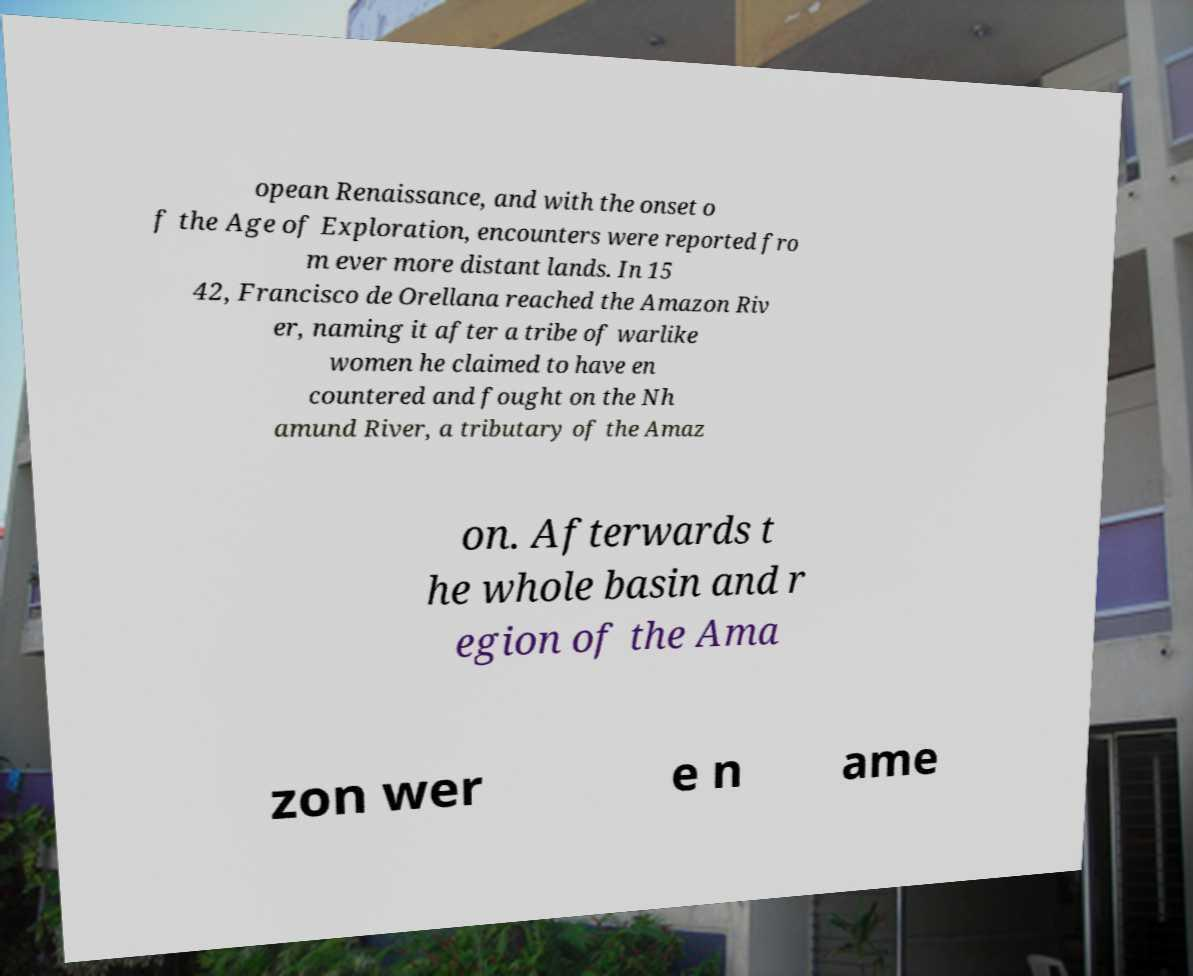Could you assist in decoding the text presented in this image and type it out clearly? opean Renaissance, and with the onset o f the Age of Exploration, encounters were reported fro m ever more distant lands. In 15 42, Francisco de Orellana reached the Amazon Riv er, naming it after a tribe of warlike women he claimed to have en countered and fought on the Nh amund River, a tributary of the Amaz on. Afterwards t he whole basin and r egion of the Ama zon wer e n ame 